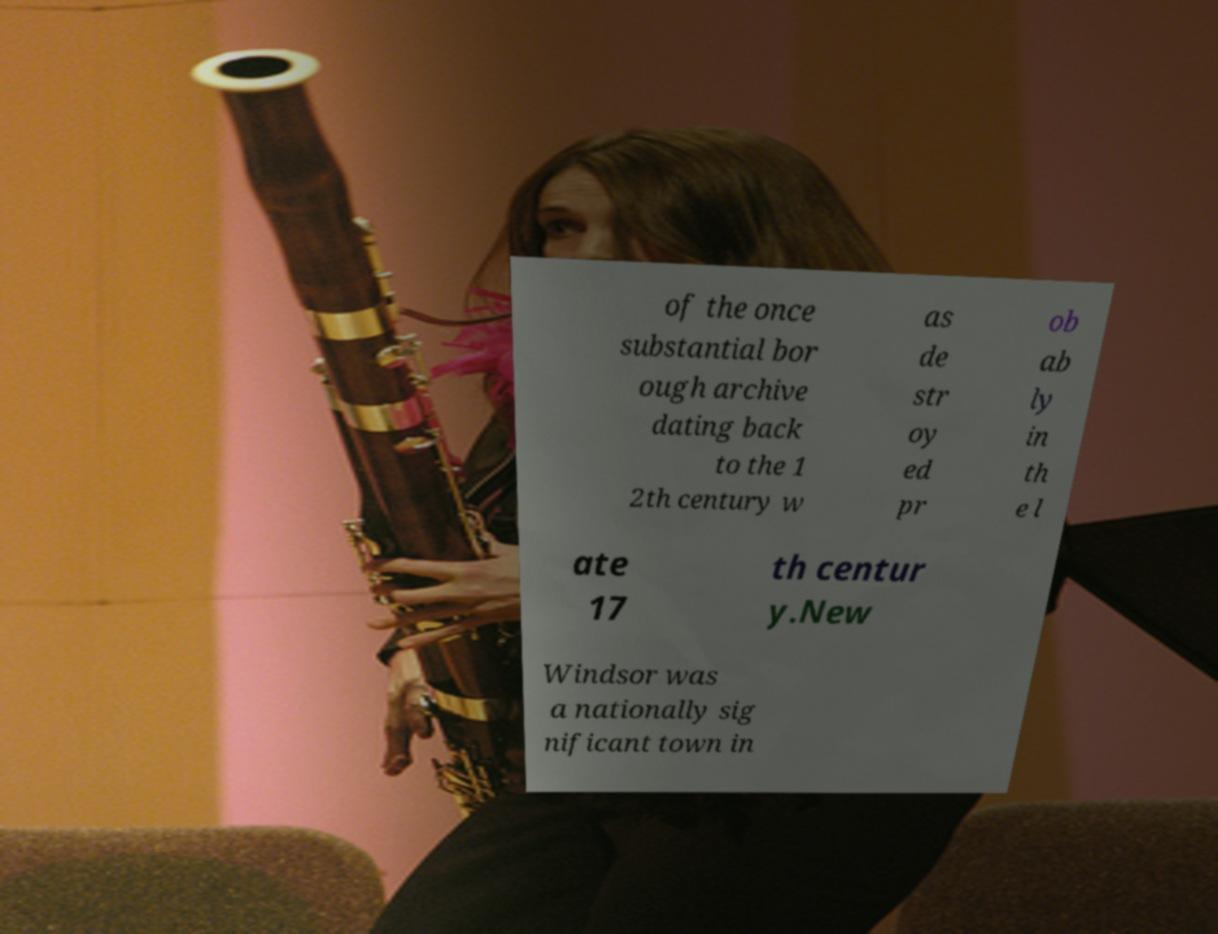For documentation purposes, I need the text within this image transcribed. Could you provide that? of the once substantial bor ough archive dating back to the 1 2th century w as de str oy ed pr ob ab ly in th e l ate 17 th centur y.New Windsor was a nationally sig nificant town in 